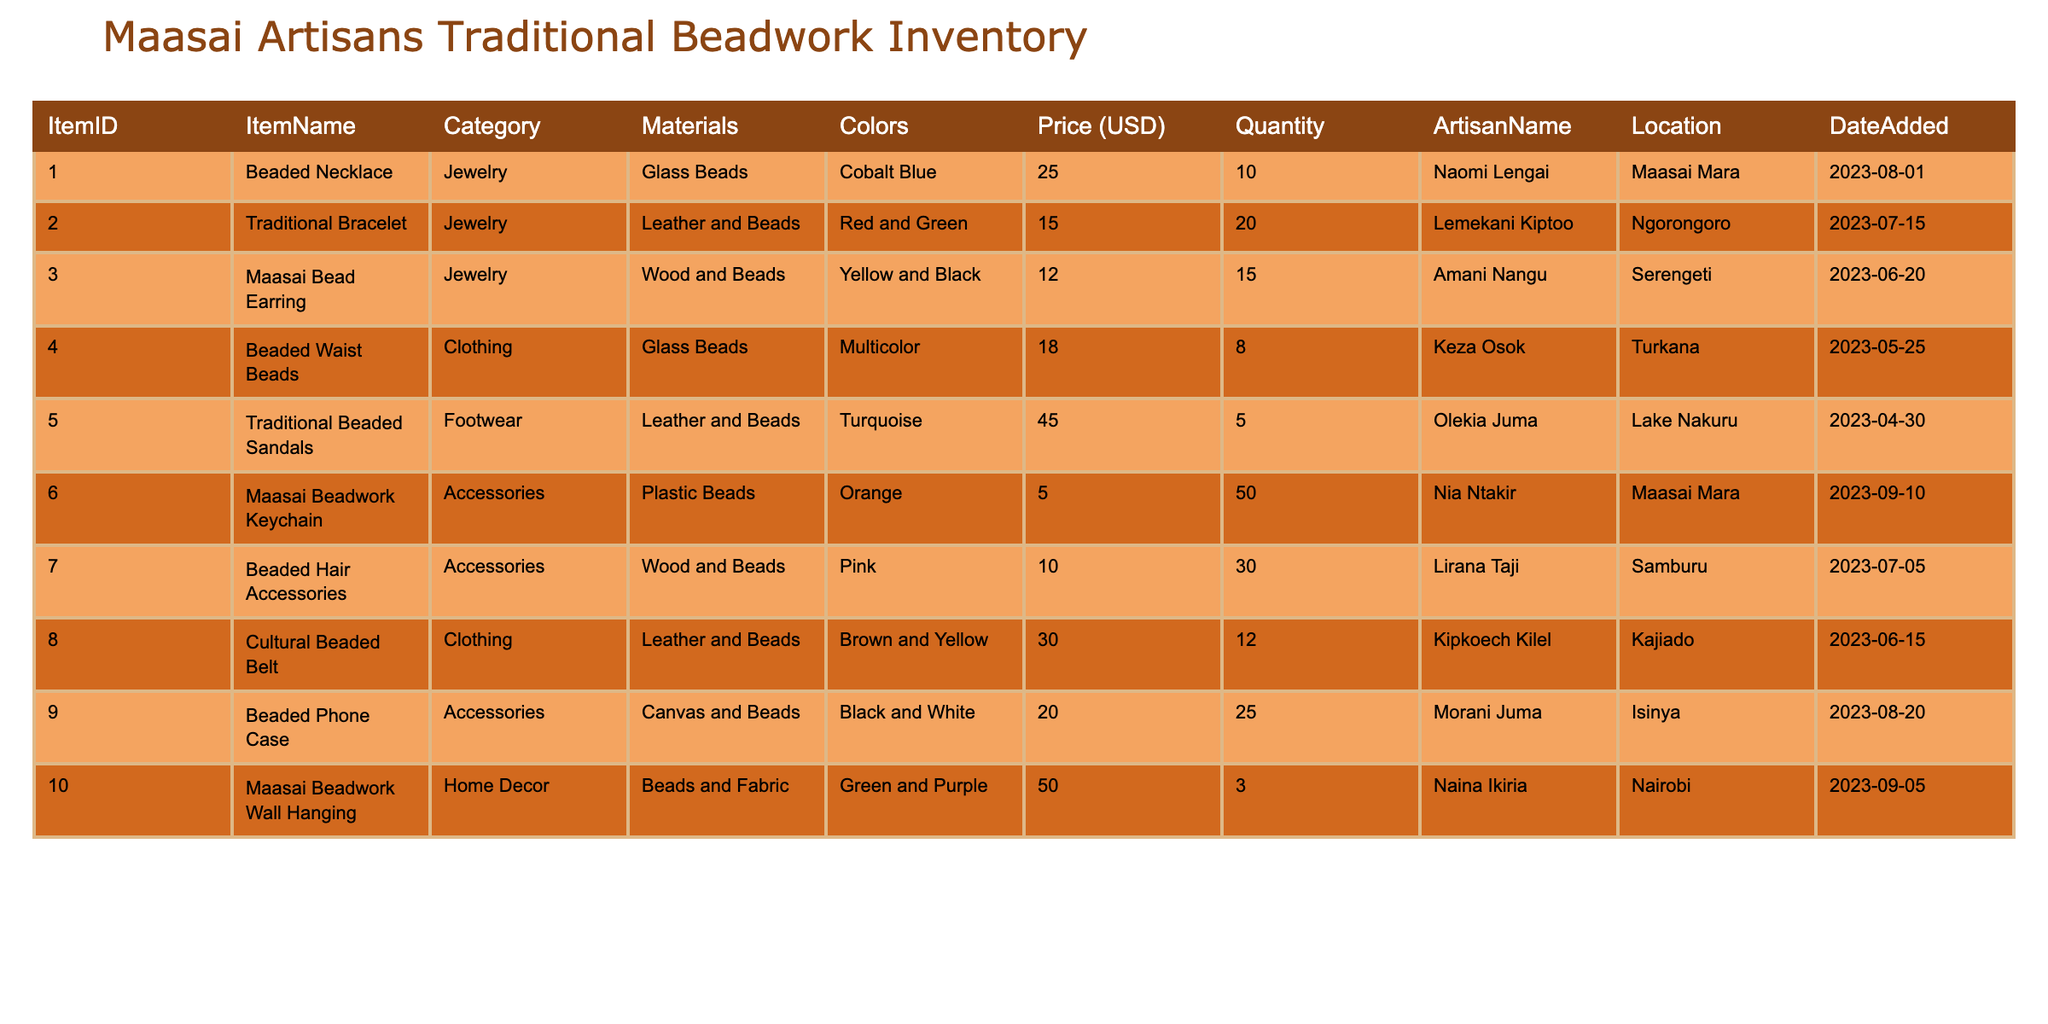What is the price of the Traditional Beaded Sandals? According to the table, the item "Traditional Beaded Sandals" has a listed price of 45.00 USD.
Answer: 45.00 USD How many Beaded Hair Accessories are available? The quantity available for "Beaded Hair Accessories" is stated in the table. It is 30.
Answer: 30 Which artisan created the Maasai Bead Earring? From the table, the artisan associated with the "Maasai Bead Earring" is Amani Nangu.
Answer: Amani Nangu What is the total quantity of items categorized as Accessories? To find this, we look at the quantities for the items in the Accessories category: 50 (Maasai Beadwork Keychain) + 30 (Beaded Hair Accessories) + 25 (Beaded Phone Case) = 105. Thus, the total quantity is 105.
Answer: 105 Is the Beaded Waist Beads item made of plastic? The materials listed for "Beaded Waist Beads" are Glass Beads, which indicates that it is not made of plastic.
Answer: No Which item has the highest price, and what is that price? By reviewing the prices in the table, the "Traditional Beaded Sandals" is priced at 45.00 USD, which is the highest.
Answer: Traditional Beaded Sandals, 45.00 USD How many different colors are used in the Cultural Beaded Belt? The table shows that the "Cultural Beaded Belt" comes in two colors: Brown and Yellow. Therefore, there are 2 colors used.
Answer: 2 What is the average price of the Jewelry category items? The prices in the Jewelry category are: 25.00 (Beaded Necklace), 15.00 (Traditional Bracelet), 12.00 (Maasai Bead Earring). Summing these gives 25 + 15 + 12 = 52. Dividing by the number of items (3) gives an average of 52/3 = 17.33.
Answer: 17.33 Are there more than 10 items in total for the item "Maasai Beadwork Keychain"? The quantity for "Maasai Beadwork Keychain" is 50, which is definitely more than 10.
Answer: Yes 